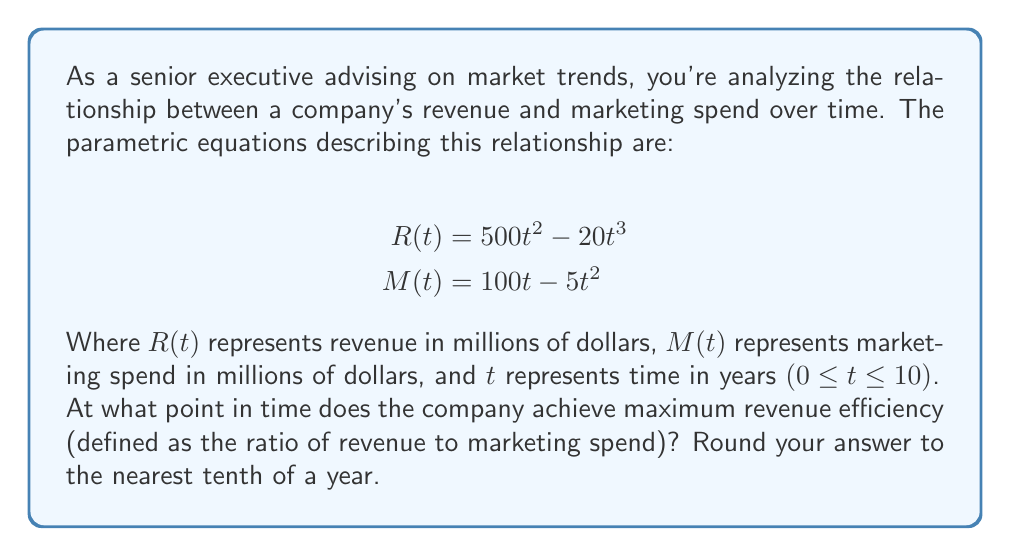Can you solve this math problem? To solve this problem, we need to follow these steps:

1) The revenue efficiency is given by the ratio $\frac{R(t)}{M(t)}$.

2) To find the maximum value of this ratio, we need to find where its derivative equals zero. Let's call this ratio $E(t)$:

   $$E(t) = \frac{R(t)}{M(t)} = \frac{500t^2 - 20t^3}{100t - 5t^2}$$

3) Using the quotient rule, the derivative of $E(t)$ is:

   $$E'(t) = \frac{(100t - 5t^2)(1000t - 60t^2) - (500t^2 - 20t^3)(100 - 10t)}{(100t - 5t^2)^2}$$

4) Simplify the numerator:

   $$(100000t^2 - 5000t^3 - 6000t^3 + 300t^4) - (50000t^2 - 2000t^3 - 5000t^3 + 200t^4)$$
   $$= 50000t^2 - 14000t^3 + 100t^4$$
   $$= 100t^2(500 - 140t + t^2)$$

5) Set this equal to zero and solve:

   $$100t^2(500 - 140t + t^2) = 0$$

   Solutions are $t = 0$ (which we can discard as it's not in our domain), and:
   
   $$500 - 140t + t^2 = 0$$

6) Using the quadratic formula:

   $$t = \frac{140 \pm \sqrt{140^2 - 4(1)(500)}}{2(1)} = \frac{140 \pm \sqrt{19600 - 2000}}{2} = \frac{140 \pm \sqrt{17600}}{2}$$

   $$= \frac{140 \pm 132.66}{2}$$

7) This gives us two solutions: $t ≈ 136.33$ or $t ≈ 3.67$

8) Since our domain is 0 ≤ t ≤ 10, the only valid solution is 3.67.

9) Rounding to the nearest tenth, we get 3.7 years.
Answer: 3.7 years 